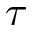<formula> <loc_0><loc_0><loc_500><loc_500>\tau</formula> 